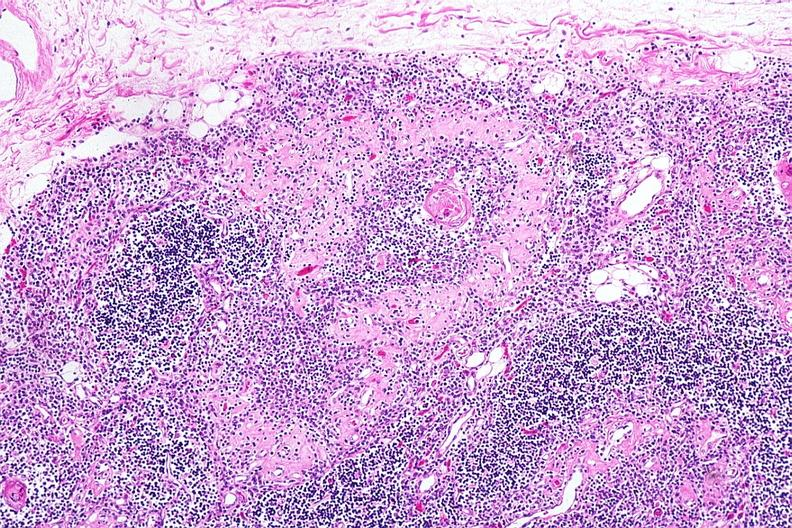s hematologic present?
Answer the question using a single word or phrase. Yes 